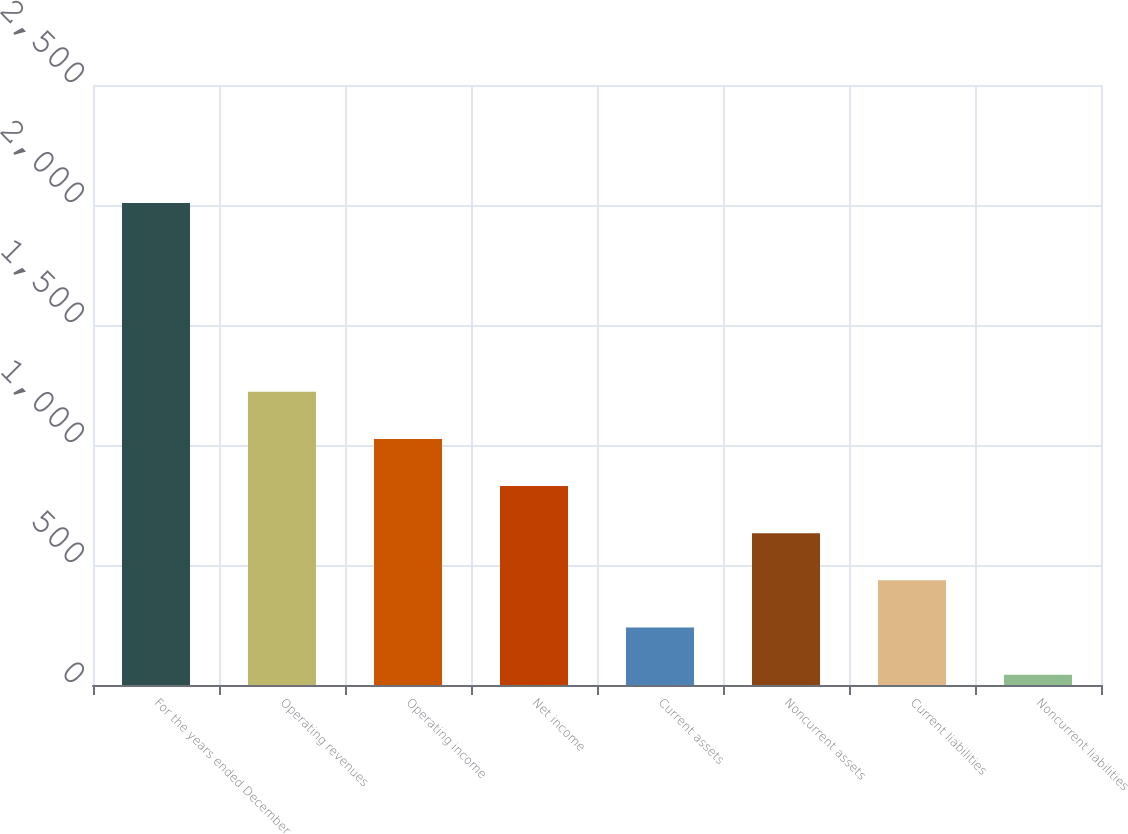<chart> <loc_0><loc_0><loc_500><loc_500><bar_chart><fcel>For the years ended December<fcel>Operating revenues<fcel>Operating income<fcel>Net income<fcel>Current assets<fcel>Noncurrent assets<fcel>Current liabilities<fcel>Noncurrent liabilities<nl><fcel>2008<fcel>1222<fcel>1025.5<fcel>829<fcel>239.5<fcel>632.5<fcel>436<fcel>43<nl></chart> 